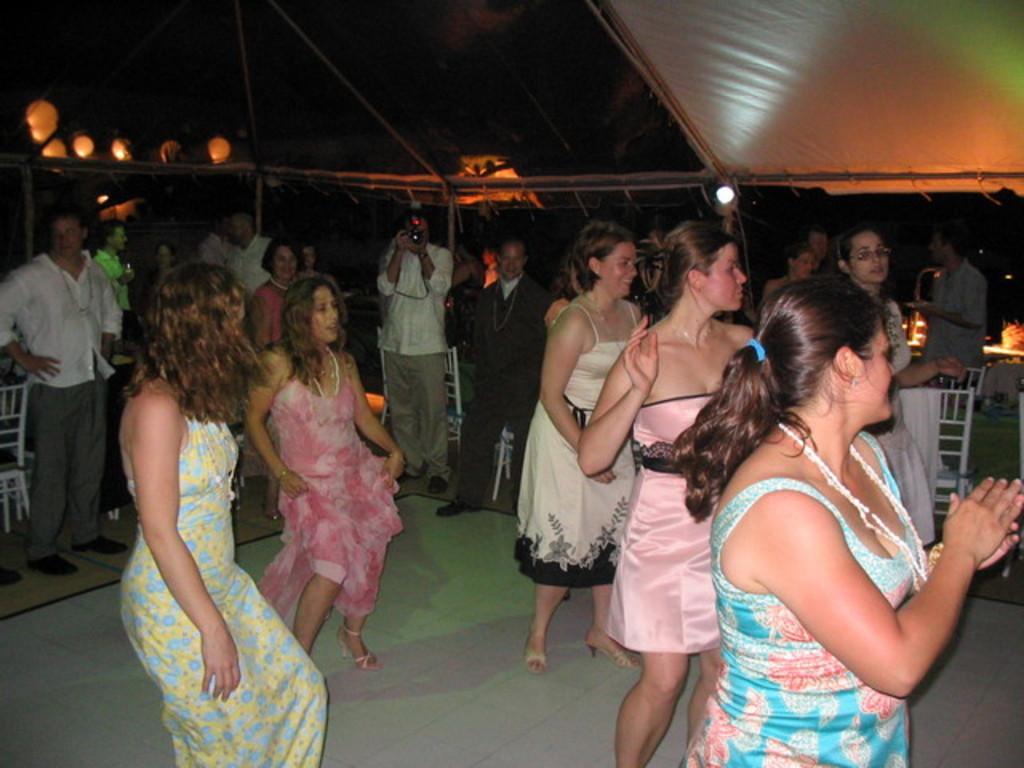In one or two sentences, can you explain what this image depicts? Here in this picture we can see a group of women dancing on the floor and behind them we can see tables and chairs present and we can also see men standing and watching them and in the middle we can see a person clicking photographs with camera in his hands and above them we can see a tent present and we can see lights also present. 